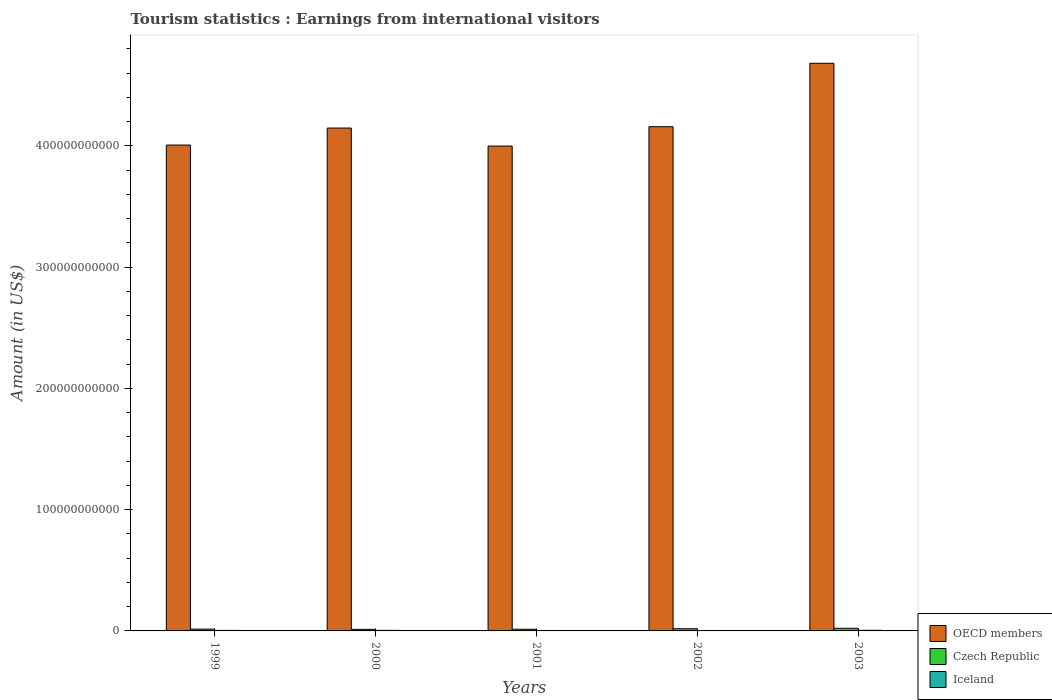What is the label of the 1st group of bars from the left?
Your answer should be compact. 1999. What is the earnings from international visitors in OECD members in 2003?
Offer a terse response. 4.68e+11. Across all years, what is the maximum earnings from international visitors in OECD members?
Offer a very short reply. 4.68e+11. Across all years, what is the minimum earnings from international visitors in Iceland?
Offer a very short reply. 3.72e+08. In which year was the earnings from international visitors in Iceland maximum?
Make the answer very short. 2003. In which year was the earnings from international visitors in Czech Republic minimum?
Your answer should be very brief. 2000. What is the total earnings from international visitors in Czech Republic in the graph?
Provide a succinct answer. 8.13e+09. What is the difference between the earnings from international visitors in OECD members in 1999 and that in 2001?
Provide a succinct answer. 8.24e+08. What is the difference between the earnings from international visitors in OECD members in 2003 and the earnings from international visitors in Iceland in 2001?
Your answer should be very brief. 4.68e+11. What is the average earnings from international visitors in Czech Republic per year?
Ensure brevity in your answer.  1.63e+09. In the year 2003, what is the difference between the earnings from international visitors in Iceland and earnings from international visitors in Czech Republic?
Your answer should be compact. -1.65e+09. In how many years, is the earnings from international visitors in Iceland greater than 440000000000 US$?
Provide a succinct answer. 0. What is the ratio of the earnings from international visitors in Iceland in 2001 to that in 2002?
Your response must be concise. 1. Is the earnings from international visitors in OECD members in 1999 less than that in 2001?
Offer a very short reply. No. What is the difference between the highest and the second highest earnings from international visitors in OECD members?
Offer a very short reply. 5.23e+1. What is the difference between the highest and the lowest earnings from international visitors in Iceland?
Your answer should be compact. 1.52e+08. What does the 1st bar from the left in 2002 represents?
Your answer should be compact. OECD members. What does the 2nd bar from the right in 1999 represents?
Your answer should be very brief. Czech Republic. How many years are there in the graph?
Offer a very short reply. 5. What is the difference between two consecutive major ticks on the Y-axis?
Your answer should be compact. 1.00e+11. Are the values on the major ticks of Y-axis written in scientific E-notation?
Your answer should be very brief. No. How are the legend labels stacked?
Make the answer very short. Vertical. What is the title of the graph?
Offer a very short reply. Tourism statistics : Earnings from international visitors. What is the label or title of the Y-axis?
Your answer should be very brief. Amount (in US$). What is the Amount (in US$) in OECD members in 1999?
Make the answer very short. 4.01e+11. What is the Amount (in US$) in Czech Republic in 1999?
Offer a terse response. 1.49e+09. What is the Amount (in US$) of Iceland in 1999?
Keep it short and to the point. 4.40e+08. What is the Amount (in US$) of OECD members in 2000?
Your answer should be compact. 4.15e+11. What is the Amount (in US$) of Czech Republic in 2000?
Provide a succinct answer. 1.28e+09. What is the Amount (in US$) of Iceland in 2000?
Your answer should be very brief. 4.71e+08. What is the Amount (in US$) in OECD members in 2001?
Provide a succinct answer. 4.00e+11. What is the Amount (in US$) of Czech Republic in 2001?
Provide a succinct answer. 1.39e+09. What is the Amount (in US$) of Iceland in 2001?
Your answer should be compact. 3.72e+08. What is the Amount (in US$) in OECD members in 2002?
Give a very brief answer. 4.16e+11. What is the Amount (in US$) in Czech Republic in 2002?
Ensure brevity in your answer.  1.80e+09. What is the Amount (in US$) in Iceland in 2002?
Make the answer very short. 3.73e+08. What is the Amount (in US$) of OECD members in 2003?
Make the answer very short. 4.68e+11. What is the Amount (in US$) of Czech Republic in 2003?
Your answer should be very brief. 2.18e+09. What is the Amount (in US$) of Iceland in 2003?
Keep it short and to the point. 5.24e+08. Across all years, what is the maximum Amount (in US$) of OECD members?
Make the answer very short. 4.68e+11. Across all years, what is the maximum Amount (in US$) of Czech Republic?
Provide a succinct answer. 2.18e+09. Across all years, what is the maximum Amount (in US$) of Iceland?
Offer a terse response. 5.24e+08. Across all years, what is the minimum Amount (in US$) in OECD members?
Provide a succinct answer. 4.00e+11. Across all years, what is the minimum Amount (in US$) in Czech Republic?
Ensure brevity in your answer.  1.28e+09. Across all years, what is the minimum Amount (in US$) in Iceland?
Provide a short and direct response. 3.72e+08. What is the total Amount (in US$) of OECD members in the graph?
Make the answer very short. 2.10e+12. What is the total Amount (in US$) of Czech Republic in the graph?
Keep it short and to the point. 8.13e+09. What is the total Amount (in US$) in Iceland in the graph?
Offer a very short reply. 2.18e+09. What is the difference between the Amount (in US$) in OECD members in 1999 and that in 2000?
Offer a terse response. -1.40e+1. What is the difference between the Amount (in US$) in Czech Republic in 1999 and that in 2000?
Make the answer very short. 2.17e+08. What is the difference between the Amount (in US$) in Iceland in 1999 and that in 2000?
Provide a succinct answer. -3.10e+07. What is the difference between the Amount (in US$) in OECD members in 1999 and that in 2001?
Offer a terse response. 8.24e+08. What is the difference between the Amount (in US$) in Czech Republic in 1999 and that in 2001?
Give a very brief answer. 1.07e+08. What is the difference between the Amount (in US$) in Iceland in 1999 and that in 2001?
Provide a succinct answer. 6.80e+07. What is the difference between the Amount (in US$) in OECD members in 1999 and that in 2002?
Your answer should be compact. -1.51e+1. What is the difference between the Amount (in US$) of Czech Republic in 1999 and that in 2002?
Your response must be concise. -3.04e+08. What is the difference between the Amount (in US$) in Iceland in 1999 and that in 2002?
Your answer should be very brief. 6.70e+07. What is the difference between the Amount (in US$) in OECD members in 1999 and that in 2003?
Your answer should be compact. -6.74e+1. What is the difference between the Amount (in US$) in Czech Republic in 1999 and that in 2003?
Offer a terse response. -6.84e+08. What is the difference between the Amount (in US$) in Iceland in 1999 and that in 2003?
Give a very brief answer. -8.40e+07. What is the difference between the Amount (in US$) of OECD members in 2000 and that in 2001?
Ensure brevity in your answer.  1.48e+1. What is the difference between the Amount (in US$) in Czech Republic in 2000 and that in 2001?
Your answer should be compact. -1.10e+08. What is the difference between the Amount (in US$) of Iceland in 2000 and that in 2001?
Your answer should be very brief. 9.90e+07. What is the difference between the Amount (in US$) in OECD members in 2000 and that in 2002?
Keep it short and to the point. -1.12e+09. What is the difference between the Amount (in US$) of Czech Republic in 2000 and that in 2002?
Offer a very short reply. -5.21e+08. What is the difference between the Amount (in US$) in Iceland in 2000 and that in 2002?
Make the answer very short. 9.80e+07. What is the difference between the Amount (in US$) in OECD members in 2000 and that in 2003?
Give a very brief answer. -5.34e+1. What is the difference between the Amount (in US$) of Czech Republic in 2000 and that in 2003?
Offer a terse response. -9.01e+08. What is the difference between the Amount (in US$) of Iceland in 2000 and that in 2003?
Offer a very short reply. -5.30e+07. What is the difference between the Amount (in US$) of OECD members in 2001 and that in 2002?
Your response must be concise. -1.60e+1. What is the difference between the Amount (in US$) in Czech Republic in 2001 and that in 2002?
Make the answer very short. -4.11e+08. What is the difference between the Amount (in US$) in Iceland in 2001 and that in 2002?
Your answer should be compact. -1.00e+06. What is the difference between the Amount (in US$) of OECD members in 2001 and that in 2003?
Offer a very short reply. -6.83e+1. What is the difference between the Amount (in US$) of Czech Republic in 2001 and that in 2003?
Your answer should be very brief. -7.91e+08. What is the difference between the Amount (in US$) of Iceland in 2001 and that in 2003?
Provide a short and direct response. -1.52e+08. What is the difference between the Amount (in US$) of OECD members in 2002 and that in 2003?
Give a very brief answer. -5.23e+1. What is the difference between the Amount (in US$) of Czech Republic in 2002 and that in 2003?
Ensure brevity in your answer.  -3.80e+08. What is the difference between the Amount (in US$) of Iceland in 2002 and that in 2003?
Provide a succinct answer. -1.51e+08. What is the difference between the Amount (in US$) in OECD members in 1999 and the Amount (in US$) in Czech Republic in 2000?
Provide a succinct answer. 3.99e+11. What is the difference between the Amount (in US$) of OECD members in 1999 and the Amount (in US$) of Iceland in 2000?
Make the answer very short. 4.00e+11. What is the difference between the Amount (in US$) of Czech Republic in 1999 and the Amount (in US$) of Iceland in 2000?
Provide a succinct answer. 1.02e+09. What is the difference between the Amount (in US$) in OECD members in 1999 and the Amount (in US$) in Czech Republic in 2001?
Make the answer very short. 3.99e+11. What is the difference between the Amount (in US$) of OECD members in 1999 and the Amount (in US$) of Iceland in 2001?
Make the answer very short. 4.00e+11. What is the difference between the Amount (in US$) of Czech Republic in 1999 and the Amount (in US$) of Iceland in 2001?
Give a very brief answer. 1.12e+09. What is the difference between the Amount (in US$) in OECD members in 1999 and the Amount (in US$) in Czech Republic in 2002?
Give a very brief answer. 3.99e+11. What is the difference between the Amount (in US$) in OECD members in 1999 and the Amount (in US$) in Iceland in 2002?
Keep it short and to the point. 4.00e+11. What is the difference between the Amount (in US$) of Czech Republic in 1999 and the Amount (in US$) of Iceland in 2002?
Your answer should be compact. 1.12e+09. What is the difference between the Amount (in US$) of OECD members in 1999 and the Amount (in US$) of Czech Republic in 2003?
Give a very brief answer. 3.98e+11. What is the difference between the Amount (in US$) of OECD members in 1999 and the Amount (in US$) of Iceland in 2003?
Your response must be concise. 4.00e+11. What is the difference between the Amount (in US$) of Czech Republic in 1999 and the Amount (in US$) of Iceland in 2003?
Provide a short and direct response. 9.69e+08. What is the difference between the Amount (in US$) in OECD members in 2000 and the Amount (in US$) in Czech Republic in 2001?
Provide a succinct answer. 4.13e+11. What is the difference between the Amount (in US$) of OECD members in 2000 and the Amount (in US$) of Iceland in 2001?
Make the answer very short. 4.14e+11. What is the difference between the Amount (in US$) of Czech Republic in 2000 and the Amount (in US$) of Iceland in 2001?
Provide a succinct answer. 9.04e+08. What is the difference between the Amount (in US$) of OECD members in 2000 and the Amount (in US$) of Czech Republic in 2002?
Offer a terse response. 4.13e+11. What is the difference between the Amount (in US$) in OECD members in 2000 and the Amount (in US$) in Iceland in 2002?
Provide a succinct answer. 4.14e+11. What is the difference between the Amount (in US$) in Czech Republic in 2000 and the Amount (in US$) in Iceland in 2002?
Give a very brief answer. 9.03e+08. What is the difference between the Amount (in US$) in OECD members in 2000 and the Amount (in US$) in Czech Republic in 2003?
Ensure brevity in your answer.  4.12e+11. What is the difference between the Amount (in US$) in OECD members in 2000 and the Amount (in US$) in Iceland in 2003?
Keep it short and to the point. 4.14e+11. What is the difference between the Amount (in US$) in Czech Republic in 2000 and the Amount (in US$) in Iceland in 2003?
Ensure brevity in your answer.  7.52e+08. What is the difference between the Amount (in US$) of OECD members in 2001 and the Amount (in US$) of Czech Republic in 2002?
Make the answer very short. 3.98e+11. What is the difference between the Amount (in US$) in OECD members in 2001 and the Amount (in US$) in Iceland in 2002?
Your answer should be very brief. 3.99e+11. What is the difference between the Amount (in US$) in Czech Republic in 2001 and the Amount (in US$) in Iceland in 2002?
Offer a terse response. 1.01e+09. What is the difference between the Amount (in US$) in OECD members in 2001 and the Amount (in US$) in Czech Republic in 2003?
Provide a short and direct response. 3.98e+11. What is the difference between the Amount (in US$) of OECD members in 2001 and the Amount (in US$) of Iceland in 2003?
Your response must be concise. 3.99e+11. What is the difference between the Amount (in US$) of Czech Republic in 2001 and the Amount (in US$) of Iceland in 2003?
Your answer should be very brief. 8.62e+08. What is the difference between the Amount (in US$) in OECD members in 2002 and the Amount (in US$) in Czech Republic in 2003?
Offer a very short reply. 4.14e+11. What is the difference between the Amount (in US$) of OECD members in 2002 and the Amount (in US$) of Iceland in 2003?
Keep it short and to the point. 4.15e+11. What is the difference between the Amount (in US$) in Czech Republic in 2002 and the Amount (in US$) in Iceland in 2003?
Provide a short and direct response. 1.27e+09. What is the average Amount (in US$) in OECD members per year?
Your answer should be compact. 4.20e+11. What is the average Amount (in US$) in Czech Republic per year?
Your answer should be very brief. 1.63e+09. What is the average Amount (in US$) in Iceland per year?
Offer a very short reply. 4.36e+08. In the year 1999, what is the difference between the Amount (in US$) in OECD members and Amount (in US$) in Czech Republic?
Make the answer very short. 3.99e+11. In the year 1999, what is the difference between the Amount (in US$) in OECD members and Amount (in US$) in Iceland?
Give a very brief answer. 4.00e+11. In the year 1999, what is the difference between the Amount (in US$) in Czech Republic and Amount (in US$) in Iceland?
Make the answer very short. 1.05e+09. In the year 2000, what is the difference between the Amount (in US$) of OECD members and Amount (in US$) of Czech Republic?
Provide a succinct answer. 4.13e+11. In the year 2000, what is the difference between the Amount (in US$) in OECD members and Amount (in US$) in Iceland?
Make the answer very short. 4.14e+11. In the year 2000, what is the difference between the Amount (in US$) in Czech Republic and Amount (in US$) in Iceland?
Your answer should be compact. 8.05e+08. In the year 2001, what is the difference between the Amount (in US$) of OECD members and Amount (in US$) of Czech Republic?
Keep it short and to the point. 3.98e+11. In the year 2001, what is the difference between the Amount (in US$) of OECD members and Amount (in US$) of Iceland?
Offer a terse response. 3.99e+11. In the year 2001, what is the difference between the Amount (in US$) in Czech Republic and Amount (in US$) in Iceland?
Provide a short and direct response. 1.01e+09. In the year 2002, what is the difference between the Amount (in US$) of OECD members and Amount (in US$) of Czech Republic?
Provide a succinct answer. 4.14e+11. In the year 2002, what is the difference between the Amount (in US$) of OECD members and Amount (in US$) of Iceland?
Your answer should be very brief. 4.15e+11. In the year 2002, what is the difference between the Amount (in US$) in Czech Republic and Amount (in US$) in Iceland?
Keep it short and to the point. 1.42e+09. In the year 2003, what is the difference between the Amount (in US$) of OECD members and Amount (in US$) of Czech Republic?
Ensure brevity in your answer.  4.66e+11. In the year 2003, what is the difference between the Amount (in US$) in OECD members and Amount (in US$) in Iceland?
Your response must be concise. 4.68e+11. In the year 2003, what is the difference between the Amount (in US$) of Czech Republic and Amount (in US$) of Iceland?
Offer a terse response. 1.65e+09. What is the ratio of the Amount (in US$) in OECD members in 1999 to that in 2000?
Make the answer very short. 0.97. What is the ratio of the Amount (in US$) in Czech Republic in 1999 to that in 2000?
Your answer should be compact. 1.17. What is the ratio of the Amount (in US$) of Iceland in 1999 to that in 2000?
Ensure brevity in your answer.  0.93. What is the ratio of the Amount (in US$) in OECD members in 1999 to that in 2001?
Provide a short and direct response. 1. What is the ratio of the Amount (in US$) in Czech Republic in 1999 to that in 2001?
Ensure brevity in your answer.  1.08. What is the ratio of the Amount (in US$) of Iceland in 1999 to that in 2001?
Ensure brevity in your answer.  1.18. What is the ratio of the Amount (in US$) of OECD members in 1999 to that in 2002?
Provide a succinct answer. 0.96. What is the ratio of the Amount (in US$) in Czech Republic in 1999 to that in 2002?
Offer a terse response. 0.83. What is the ratio of the Amount (in US$) of Iceland in 1999 to that in 2002?
Ensure brevity in your answer.  1.18. What is the ratio of the Amount (in US$) of OECD members in 1999 to that in 2003?
Your response must be concise. 0.86. What is the ratio of the Amount (in US$) of Czech Republic in 1999 to that in 2003?
Your answer should be compact. 0.69. What is the ratio of the Amount (in US$) of Iceland in 1999 to that in 2003?
Offer a very short reply. 0.84. What is the ratio of the Amount (in US$) of OECD members in 2000 to that in 2001?
Make the answer very short. 1.04. What is the ratio of the Amount (in US$) of Czech Republic in 2000 to that in 2001?
Provide a short and direct response. 0.92. What is the ratio of the Amount (in US$) in Iceland in 2000 to that in 2001?
Ensure brevity in your answer.  1.27. What is the ratio of the Amount (in US$) in OECD members in 2000 to that in 2002?
Offer a terse response. 1. What is the ratio of the Amount (in US$) of Czech Republic in 2000 to that in 2002?
Make the answer very short. 0.71. What is the ratio of the Amount (in US$) of Iceland in 2000 to that in 2002?
Ensure brevity in your answer.  1.26. What is the ratio of the Amount (in US$) in OECD members in 2000 to that in 2003?
Ensure brevity in your answer.  0.89. What is the ratio of the Amount (in US$) of Czech Republic in 2000 to that in 2003?
Your answer should be compact. 0.59. What is the ratio of the Amount (in US$) of Iceland in 2000 to that in 2003?
Provide a succinct answer. 0.9. What is the ratio of the Amount (in US$) of OECD members in 2001 to that in 2002?
Provide a succinct answer. 0.96. What is the ratio of the Amount (in US$) in Czech Republic in 2001 to that in 2002?
Give a very brief answer. 0.77. What is the ratio of the Amount (in US$) of OECD members in 2001 to that in 2003?
Your response must be concise. 0.85. What is the ratio of the Amount (in US$) of Czech Republic in 2001 to that in 2003?
Keep it short and to the point. 0.64. What is the ratio of the Amount (in US$) in Iceland in 2001 to that in 2003?
Make the answer very short. 0.71. What is the ratio of the Amount (in US$) of OECD members in 2002 to that in 2003?
Make the answer very short. 0.89. What is the ratio of the Amount (in US$) of Czech Republic in 2002 to that in 2003?
Make the answer very short. 0.83. What is the ratio of the Amount (in US$) of Iceland in 2002 to that in 2003?
Ensure brevity in your answer.  0.71. What is the difference between the highest and the second highest Amount (in US$) in OECD members?
Keep it short and to the point. 5.23e+1. What is the difference between the highest and the second highest Amount (in US$) in Czech Republic?
Give a very brief answer. 3.80e+08. What is the difference between the highest and the second highest Amount (in US$) in Iceland?
Your answer should be compact. 5.30e+07. What is the difference between the highest and the lowest Amount (in US$) of OECD members?
Give a very brief answer. 6.83e+1. What is the difference between the highest and the lowest Amount (in US$) of Czech Republic?
Provide a short and direct response. 9.01e+08. What is the difference between the highest and the lowest Amount (in US$) in Iceland?
Provide a succinct answer. 1.52e+08. 